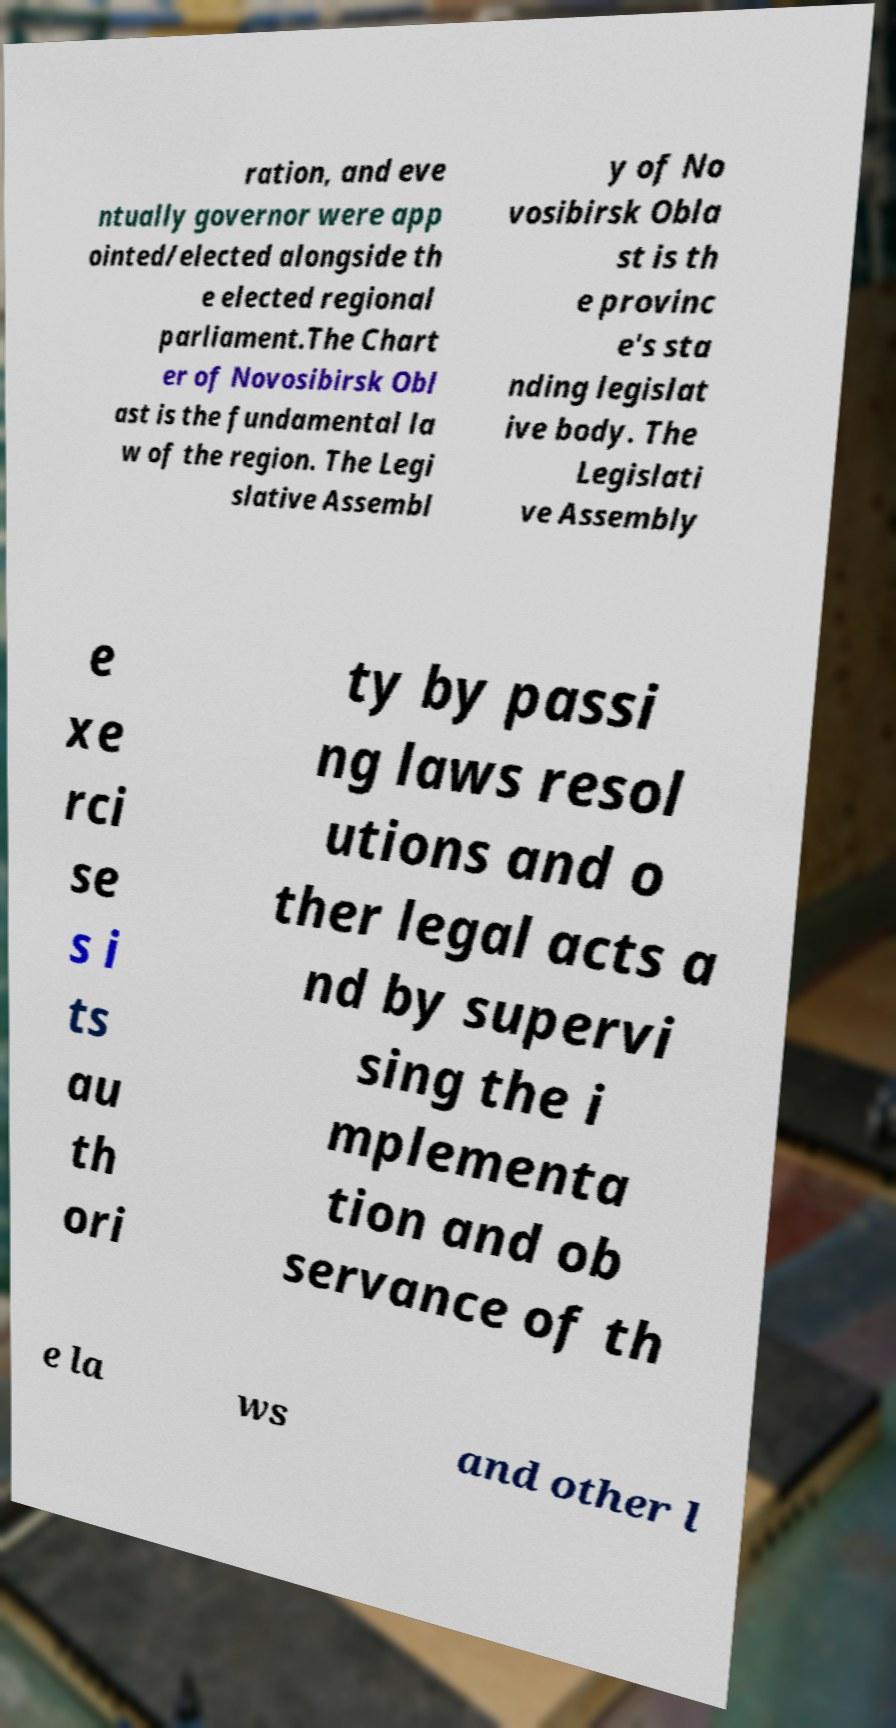Could you extract and type out the text from this image? ration, and eve ntually governor were app ointed/elected alongside th e elected regional parliament.The Chart er of Novosibirsk Obl ast is the fundamental la w of the region. The Legi slative Assembl y of No vosibirsk Obla st is th e provinc e's sta nding legislat ive body. The Legislati ve Assembly e xe rci se s i ts au th ori ty by passi ng laws resol utions and o ther legal acts a nd by supervi sing the i mplementa tion and ob servance of th e la ws and other l 